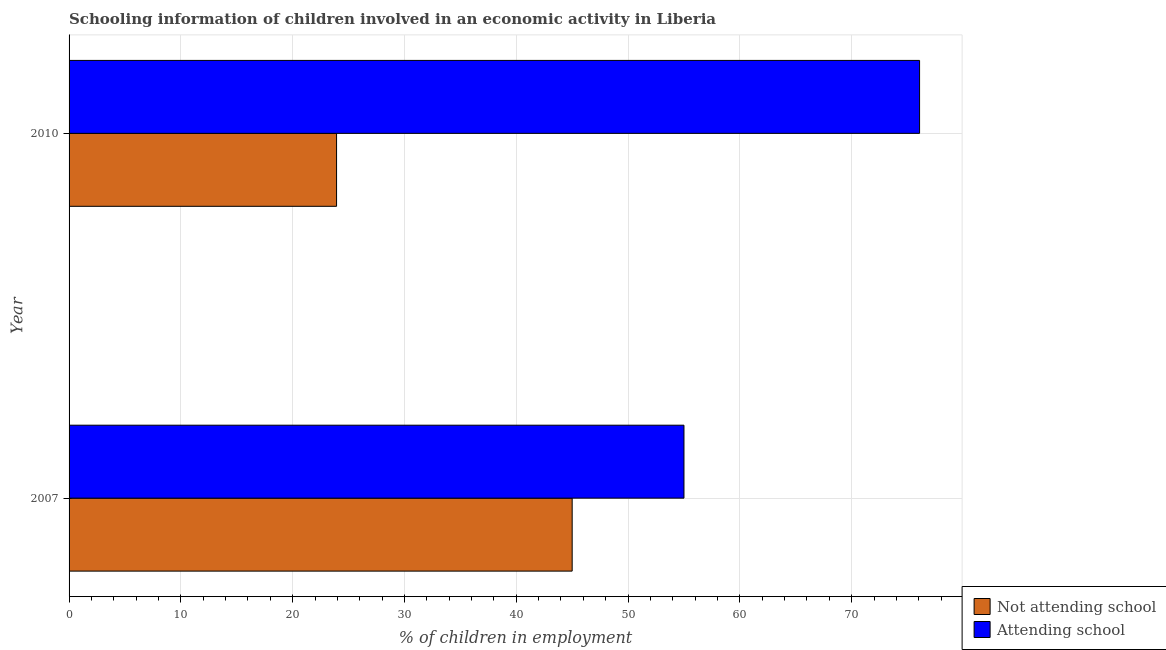How many different coloured bars are there?
Your answer should be compact. 2. Are the number of bars on each tick of the Y-axis equal?
Your answer should be very brief. Yes. How many bars are there on the 2nd tick from the top?
Offer a very short reply. 2. How many bars are there on the 2nd tick from the bottom?
Provide a succinct answer. 2. What is the label of the 2nd group of bars from the top?
Make the answer very short. 2007. In how many cases, is the number of bars for a given year not equal to the number of legend labels?
Give a very brief answer. 0. What is the percentage of employed children who are not attending school in 2010?
Offer a very short reply. 23.93. Across all years, what is the maximum percentage of employed children who are not attending school?
Provide a short and direct response. 45. Across all years, what is the minimum percentage of employed children who are not attending school?
Your response must be concise. 23.93. In which year was the percentage of employed children who are not attending school maximum?
Keep it short and to the point. 2007. What is the total percentage of employed children who are attending school in the graph?
Your response must be concise. 131.07. What is the difference between the percentage of employed children who are attending school in 2007 and that in 2010?
Your answer should be compact. -21.07. What is the difference between the percentage of employed children who are attending school in 2010 and the percentage of employed children who are not attending school in 2007?
Give a very brief answer. 31.07. What is the average percentage of employed children who are attending school per year?
Your response must be concise. 65.54. In how many years, is the percentage of employed children who are not attending school greater than 30 %?
Your answer should be compact. 1. What is the ratio of the percentage of employed children who are attending school in 2007 to that in 2010?
Your response must be concise. 0.72. Is the percentage of employed children who are not attending school in 2007 less than that in 2010?
Your answer should be very brief. No. Is the difference between the percentage of employed children who are attending school in 2007 and 2010 greater than the difference between the percentage of employed children who are not attending school in 2007 and 2010?
Make the answer very short. No. In how many years, is the percentage of employed children who are not attending school greater than the average percentage of employed children who are not attending school taken over all years?
Provide a succinct answer. 1. What does the 2nd bar from the top in 2007 represents?
Make the answer very short. Not attending school. What does the 1st bar from the bottom in 2007 represents?
Provide a succinct answer. Not attending school. How many years are there in the graph?
Offer a terse response. 2. What is the difference between two consecutive major ticks on the X-axis?
Give a very brief answer. 10. Are the values on the major ticks of X-axis written in scientific E-notation?
Your answer should be compact. No. How many legend labels are there?
Offer a terse response. 2. What is the title of the graph?
Keep it short and to the point. Schooling information of children involved in an economic activity in Liberia. What is the label or title of the X-axis?
Make the answer very short. % of children in employment. What is the label or title of the Y-axis?
Give a very brief answer. Year. What is the % of children in employment of Not attending school in 2007?
Your answer should be compact. 45. What is the % of children in employment of Not attending school in 2010?
Your answer should be compact. 23.93. What is the % of children in employment of Attending school in 2010?
Keep it short and to the point. 76.07. Across all years, what is the maximum % of children in employment in Not attending school?
Make the answer very short. 45. Across all years, what is the maximum % of children in employment in Attending school?
Provide a short and direct response. 76.07. Across all years, what is the minimum % of children in employment of Not attending school?
Your response must be concise. 23.93. What is the total % of children in employment in Not attending school in the graph?
Keep it short and to the point. 68.93. What is the total % of children in employment in Attending school in the graph?
Make the answer very short. 131.07. What is the difference between the % of children in employment of Not attending school in 2007 and that in 2010?
Ensure brevity in your answer.  21.07. What is the difference between the % of children in employment of Attending school in 2007 and that in 2010?
Ensure brevity in your answer.  -21.07. What is the difference between the % of children in employment of Not attending school in 2007 and the % of children in employment of Attending school in 2010?
Provide a short and direct response. -31.07. What is the average % of children in employment of Not attending school per year?
Make the answer very short. 34.46. What is the average % of children in employment in Attending school per year?
Make the answer very short. 65.54. In the year 2007, what is the difference between the % of children in employment in Not attending school and % of children in employment in Attending school?
Provide a succinct answer. -10. In the year 2010, what is the difference between the % of children in employment in Not attending school and % of children in employment in Attending school?
Make the answer very short. -52.15. What is the ratio of the % of children in employment in Not attending school in 2007 to that in 2010?
Make the answer very short. 1.88. What is the ratio of the % of children in employment in Attending school in 2007 to that in 2010?
Provide a short and direct response. 0.72. What is the difference between the highest and the second highest % of children in employment in Not attending school?
Offer a terse response. 21.07. What is the difference between the highest and the second highest % of children in employment of Attending school?
Ensure brevity in your answer.  21.07. What is the difference between the highest and the lowest % of children in employment of Not attending school?
Make the answer very short. 21.07. What is the difference between the highest and the lowest % of children in employment in Attending school?
Provide a succinct answer. 21.07. 